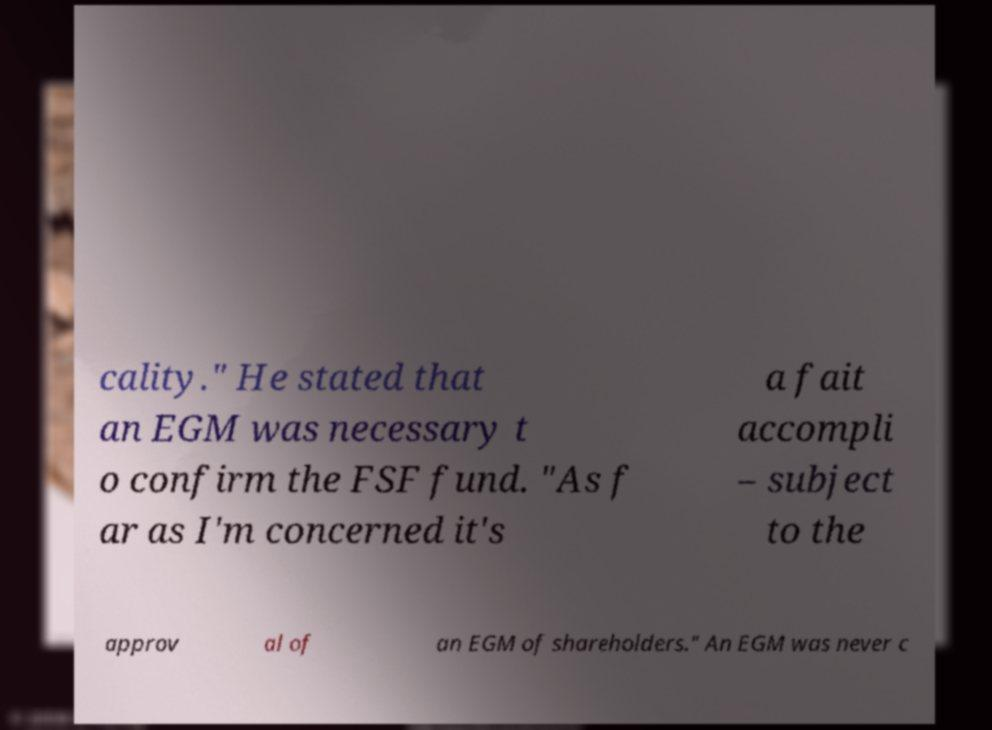For documentation purposes, I need the text within this image transcribed. Could you provide that? cality." He stated that an EGM was necessary t o confirm the FSF fund. "As f ar as I'm concerned it's a fait accompli – subject to the approv al of an EGM of shareholders." An EGM was never c 